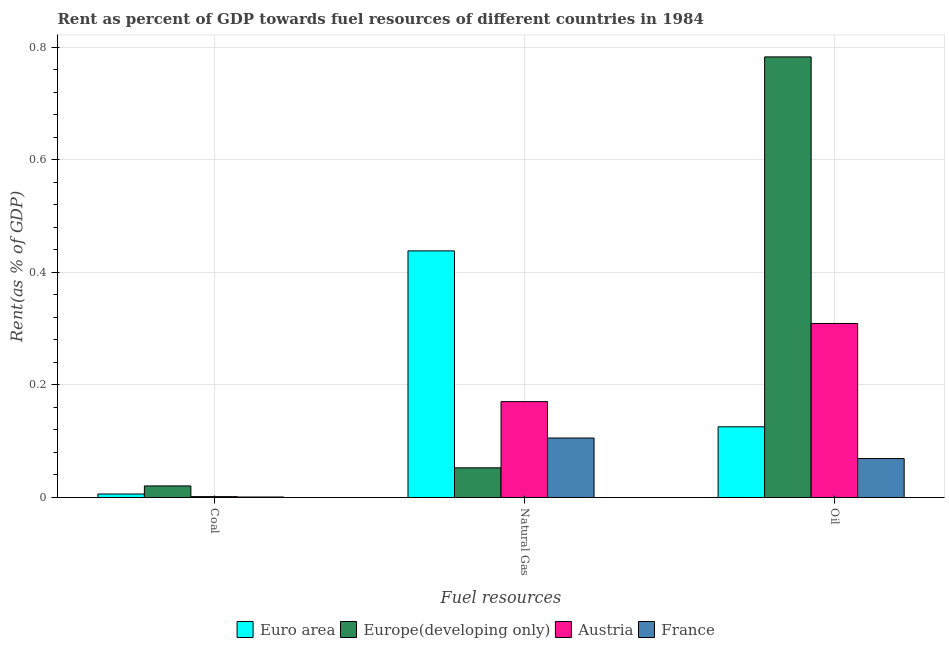How many bars are there on the 1st tick from the left?
Your answer should be very brief. 4. How many bars are there on the 1st tick from the right?
Offer a terse response. 4. What is the label of the 3rd group of bars from the left?
Your response must be concise. Oil. What is the rent towards oil in France?
Offer a very short reply. 0.07. Across all countries, what is the maximum rent towards coal?
Ensure brevity in your answer.  0.02. Across all countries, what is the minimum rent towards oil?
Your answer should be very brief. 0.07. In which country was the rent towards coal maximum?
Ensure brevity in your answer.  Europe(developing only). In which country was the rent towards natural gas minimum?
Provide a succinct answer. Europe(developing only). What is the total rent towards coal in the graph?
Ensure brevity in your answer.  0.03. What is the difference between the rent towards coal in Euro area and that in Austria?
Provide a short and direct response. 0. What is the difference between the rent towards oil in Euro area and the rent towards coal in Austria?
Offer a terse response. 0.12. What is the average rent towards coal per country?
Provide a succinct answer. 0.01. What is the difference between the rent towards oil and rent towards natural gas in Euro area?
Offer a very short reply. -0.31. What is the ratio of the rent towards oil in Europe(developing only) to that in Austria?
Your answer should be very brief. 2.53. Is the rent towards coal in Austria less than that in Europe(developing only)?
Keep it short and to the point. Yes. Is the difference between the rent towards natural gas in Austria and Europe(developing only) greater than the difference between the rent towards coal in Austria and Europe(developing only)?
Make the answer very short. Yes. What is the difference between the highest and the second highest rent towards natural gas?
Make the answer very short. 0.27. What is the difference between the highest and the lowest rent towards natural gas?
Your answer should be compact. 0.39. In how many countries, is the rent towards natural gas greater than the average rent towards natural gas taken over all countries?
Your answer should be compact. 1. What does the 3rd bar from the left in Coal represents?
Ensure brevity in your answer.  Austria. What does the 3rd bar from the right in Coal represents?
Offer a very short reply. Europe(developing only). How many bars are there?
Offer a very short reply. 12. Does the graph contain grids?
Provide a succinct answer. Yes. How many legend labels are there?
Offer a terse response. 4. How are the legend labels stacked?
Offer a terse response. Horizontal. What is the title of the graph?
Make the answer very short. Rent as percent of GDP towards fuel resources of different countries in 1984. Does "Papua New Guinea" appear as one of the legend labels in the graph?
Your answer should be very brief. No. What is the label or title of the X-axis?
Your response must be concise. Fuel resources. What is the label or title of the Y-axis?
Offer a terse response. Rent(as % of GDP). What is the Rent(as % of GDP) in Euro area in Coal?
Offer a very short reply. 0.01. What is the Rent(as % of GDP) of Europe(developing only) in Coal?
Keep it short and to the point. 0.02. What is the Rent(as % of GDP) of Austria in Coal?
Your answer should be very brief. 0. What is the Rent(as % of GDP) in France in Coal?
Make the answer very short. 0. What is the Rent(as % of GDP) of Euro area in Natural Gas?
Offer a terse response. 0.44. What is the Rent(as % of GDP) of Europe(developing only) in Natural Gas?
Keep it short and to the point. 0.05. What is the Rent(as % of GDP) of Austria in Natural Gas?
Provide a short and direct response. 0.17. What is the Rent(as % of GDP) in France in Natural Gas?
Keep it short and to the point. 0.11. What is the Rent(as % of GDP) in Euro area in Oil?
Offer a terse response. 0.13. What is the Rent(as % of GDP) in Europe(developing only) in Oil?
Make the answer very short. 0.78. What is the Rent(as % of GDP) in Austria in Oil?
Keep it short and to the point. 0.31. What is the Rent(as % of GDP) in France in Oil?
Offer a terse response. 0.07. Across all Fuel resources, what is the maximum Rent(as % of GDP) of Euro area?
Make the answer very short. 0.44. Across all Fuel resources, what is the maximum Rent(as % of GDP) in Europe(developing only)?
Offer a terse response. 0.78. Across all Fuel resources, what is the maximum Rent(as % of GDP) in Austria?
Provide a short and direct response. 0.31. Across all Fuel resources, what is the maximum Rent(as % of GDP) of France?
Keep it short and to the point. 0.11. Across all Fuel resources, what is the minimum Rent(as % of GDP) of Euro area?
Your response must be concise. 0.01. Across all Fuel resources, what is the minimum Rent(as % of GDP) in Europe(developing only)?
Provide a succinct answer. 0.02. Across all Fuel resources, what is the minimum Rent(as % of GDP) in Austria?
Offer a terse response. 0. Across all Fuel resources, what is the minimum Rent(as % of GDP) of France?
Ensure brevity in your answer.  0. What is the total Rent(as % of GDP) of Euro area in the graph?
Ensure brevity in your answer.  0.57. What is the total Rent(as % of GDP) of Europe(developing only) in the graph?
Provide a short and direct response. 0.86. What is the total Rent(as % of GDP) of Austria in the graph?
Your answer should be compact. 0.48. What is the total Rent(as % of GDP) of France in the graph?
Your answer should be very brief. 0.18. What is the difference between the Rent(as % of GDP) in Euro area in Coal and that in Natural Gas?
Keep it short and to the point. -0.43. What is the difference between the Rent(as % of GDP) of Europe(developing only) in Coal and that in Natural Gas?
Offer a very short reply. -0.03. What is the difference between the Rent(as % of GDP) of Austria in Coal and that in Natural Gas?
Provide a succinct answer. -0.17. What is the difference between the Rent(as % of GDP) of France in Coal and that in Natural Gas?
Offer a terse response. -0.1. What is the difference between the Rent(as % of GDP) of Euro area in Coal and that in Oil?
Provide a short and direct response. -0.12. What is the difference between the Rent(as % of GDP) in Europe(developing only) in Coal and that in Oil?
Offer a very short reply. -0.76. What is the difference between the Rent(as % of GDP) of Austria in Coal and that in Oil?
Your answer should be very brief. -0.31. What is the difference between the Rent(as % of GDP) of France in Coal and that in Oil?
Your answer should be very brief. -0.07. What is the difference between the Rent(as % of GDP) in Euro area in Natural Gas and that in Oil?
Provide a short and direct response. 0.31. What is the difference between the Rent(as % of GDP) of Europe(developing only) in Natural Gas and that in Oil?
Give a very brief answer. -0.73. What is the difference between the Rent(as % of GDP) in Austria in Natural Gas and that in Oil?
Your answer should be very brief. -0.14. What is the difference between the Rent(as % of GDP) in France in Natural Gas and that in Oil?
Ensure brevity in your answer.  0.04. What is the difference between the Rent(as % of GDP) in Euro area in Coal and the Rent(as % of GDP) in Europe(developing only) in Natural Gas?
Make the answer very short. -0.05. What is the difference between the Rent(as % of GDP) in Euro area in Coal and the Rent(as % of GDP) in Austria in Natural Gas?
Ensure brevity in your answer.  -0.16. What is the difference between the Rent(as % of GDP) in Euro area in Coal and the Rent(as % of GDP) in France in Natural Gas?
Your response must be concise. -0.1. What is the difference between the Rent(as % of GDP) in Europe(developing only) in Coal and the Rent(as % of GDP) in Austria in Natural Gas?
Your response must be concise. -0.15. What is the difference between the Rent(as % of GDP) in Europe(developing only) in Coal and the Rent(as % of GDP) in France in Natural Gas?
Provide a succinct answer. -0.09. What is the difference between the Rent(as % of GDP) of Austria in Coal and the Rent(as % of GDP) of France in Natural Gas?
Ensure brevity in your answer.  -0.1. What is the difference between the Rent(as % of GDP) of Euro area in Coal and the Rent(as % of GDP) of Europe(developing only) in Oil?
Your answer should be compact. -0.78. What is the difference between the Rent(as % of GDP) in Euro area in Coal and the Rent(as % of GDP) in Austria in Oil?
Your response must be concise. -0.3. What is the difference between the Rent(as % of GDP) of Euro area in Coal and the Rent(as % of GDP) of France in Oil?
Your answer should be very brief. -0.06. What is the difference between the Rent(as % of GDP) in Europe(developing only) in Coal and the Rent(as % of GDP) in Austria in Oil?
Keep it short and to the point. -0.29. What is the difference between the Rent(as % of GDP) in Europe(developing only) in Coal and the Rent(as % of GDP) in France in Oil?
Provide a succinct answer. -0.05. What is the difference between the Rent(as % of GDP) of Austria in Coal and the Rent(as % of GDP) of France in Oil?
Your response must be concise. -0.07. What is the difference between the Rent(as % of GDP) of Euro area in Natural Gas and the Rent(as % of GDP) of Europe(developing only) in Oil?
Offer a terse response. -0.34. What is the difference between the Rent(as % of GDP) of Euro area in Natural Gas and the Rent(as % of GDP) of Austria in Oil?
Your answer should be compact. 0.13. What is the difference between the Rent(as % of GDP) in Euro area in Natural Gas and the Rent(as % of GDP) in France in Oil?
Your response must be concise. 0.37. What is the difference between the Rent(as % of GDP) of Europe(developing only) in Natural Gas and the Rent(as % of GDP) of Austria in Oil?
Your answer should be very brief. -0.26. What is the difference between the Rent(as % of GDP) of Europe(developing only) in Natural Gas and the Rent(as % of GDP) of France in Oil?
Provide a short and direct response. -0.02. What is the difference between the Rent(as % of GDP) of Austria in Natural Gas and the Rent(as % of GDP) of France in Oil?
Your answer should be very brief. 0.1. What is the average Rent(as % of GDP) of Euro area per Fuel resources?
Offer a terse response. 0.19. What is the average Rent(as % of GDP) in Europe(developing only) per Fuel resources?
Your answer should be compact. 0.29. What is the average Rent(as % of GDP) of Austria per Fuel resources?
Keep it short and to the point. 0.16. What is the average Rent(as % of GDP) in France per Fuel resources?
Your response must be concise. 0.06. What is the difference between the Rent(as % of GDP) in Euro area and Rent(as % of GDP) in Europe(developing only) in Coal?
Give a very brief answer. -0.01. What is the difference between the Rent(as % of GDP) in Euro area and Rent(as % of GDP) in Austria in Coal?
Make the answer very short. 0. What is the difference between the Rent(as % of GDP) in Euro area and Rent(as % of GDP) in France in Coal?
Ensure brevity in your answer.  0.01. What is the difference between the Rent(as % of GDP) in Europe(developing only) and Rent(as % of GDP) in Austria in Coal?
Keep it short and to the point. 0.02. What is the difference between the Rent(as % of GDP) in Europe(developing only) and Rent(as % of GDP) in France in Coal?
Keep it short and to the point. 0.02. What is the difference between the Rent(as % of GDP) in Austria and Rent(as % of GDP) in France in Coal?
Provide a succinct answer. 0. What is the difference between the Rent(as % of GDP) of Euro area and Rent(as % of GDP) of Europe(developing only) in Natural Gas?
Your answer should be compact. 0.39. What is the difference between the Rent(as % of GDP) of Euro area and Rent(as % of GDP) of Austria in Natural Gas?
Keep it short and to the point. 0.27. What is the difference between the Rent(as % of GDP) of Euro area and Rent(as % of GDP) of France in Natural Gas?
Provide a succinct answer. 0.33. What is the difference between the Rent(as % of GDP) of Europe(developing only) and Rent(as % of GDP) of Austria in Natural Gas?
Make the answer very short. -0.12. What is the difference between the Rent(as % of GDP) in Europe(developing only) and Rent(as % of GDP) in France in Natural Gas?
Make the answer very short. -0.05. What is the difference between the Rent(as % of GDP) of Austria and Rent(as % of GDP) of France in Natural Gas?
Provide a short and direct response. 0.06. What is the difference between the Rent(as % of GDP) of Euro area and Rent(as % of GDP) of Europe(developing only) in Oil?
Keep it short and to the point. -0.66. What is the difference between the Rent(as % of GDP) of Euro area and Rent(as % of GDP) of Austria in Oil?
Provide a succinct answer. -0.18. What is the difference between the Rent(as % of GDP) of Euro area and Rent(as % of GDP) of France in Oil?
Offer a very short reply. 0.06. What is the difference between the Rent(as % of GDP) of Europe(developing only) and Rent(as % of GDP) of Austria in Oil?
Provide a succinct answer. 0.47. What is the difference between the Rent(as % of GDP) in Europe(developing only) and Rent(as % of GDP) in France in Oil?
Provide a short and direct response. 0.71. What is the difference between the Rent(as % of GDP) in Austria and Rent(as % of GDP) in France in Oil?
Provide a short and direct response. 0.24. What is the ratio of the Rent(as % of GDP) in Euro area in Coal to that in Natural Gas?
Your response must be concise. 0.01. What is the ratio of the Rent(as % of GDP) of Europe(developing only) in Coal to that in Natural Gas?
Offer a very short reply. 0.39. What is the ratio of the Rent(as % of GDP) in Austria in Coal to that in Natural Gas?
Make the answer very short. 0.01. What is the ratio of the Rent(as % of GDP) of France in Coal to that in Natural Gas?
Your answer should be very brief. 0.01. What is the ratio of the Rent(as % of GDP) of Euro area in Coal to that in Oil?
Ensure brevity in your answer.  0.05. What is the ratio of the Rent(as % of GDP) in Europe(developing only) in Coal to that in Oil?
Provide a succinct answer. 0.03. What is the ratio of the Rent(as % of GDP) of Austria in Coal to that in Oil?
Offer a terse response. 0.01. What is the ratio of the Rent(as % of GDP) of France in Coal to that in Oil?
Provide a short and direct response. 0.01. What is the ratio of the Rent(as % of GDP) of Euro area in Natural Gas to that in Oil?
Provide a succinct answer. 3.49. What is the ratio of the Rent(as % of GDP) of Europe(developing only) in Natural Gas to that in Oil?
Your answer should be very brief. 0.07. What is the ratio of the Rent(as % of GDP) of Austria in Natural Gas to that in Oil?
Your answer should be compact. 0.55. What is the ratio of the Rent(as % of GDP) of France in Natural Gas to that in Oil?
Your answer should be very brief. 1.53. What is the difference between the highest and the second highest Rent(as % of GDP) in Euro area?
Provide a short and direct response. 0.31. What is the difference between the highest and the second highest Rent(as % of GDP) in Europe(developing only)?
Your response must be concise. 0.73. What is the difference between the highest and the second highest Rent(as % of GDP) in Austria?
Your answer should be very brief. 0.14. What is the difference between the highest and the second highest Rent(as % of GDP) of France?
Ensure brevity in your answer.  0.04. What is the difference between the highest and the lowest Rent(as % of GDP) of Euro area?
Give a very brief answer. 0.43. What is the difference between the highest and the lowest Rent(as % of GDP) of Europe(developing only)?
Make the answer very short. 0.76. What is the difference between the highest and the lowest Rent(as % of GDP) in Austria?
Give a very brief answer. 0.31. What is the difference between the highest and the lowest Rent(as % of GDP) in France?
Your answer should be compact. 0.1. 